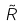Convert formula to latex. <formula><loc_0><loc_0><loc_500><loc_500>\tilde { R }</formula> 